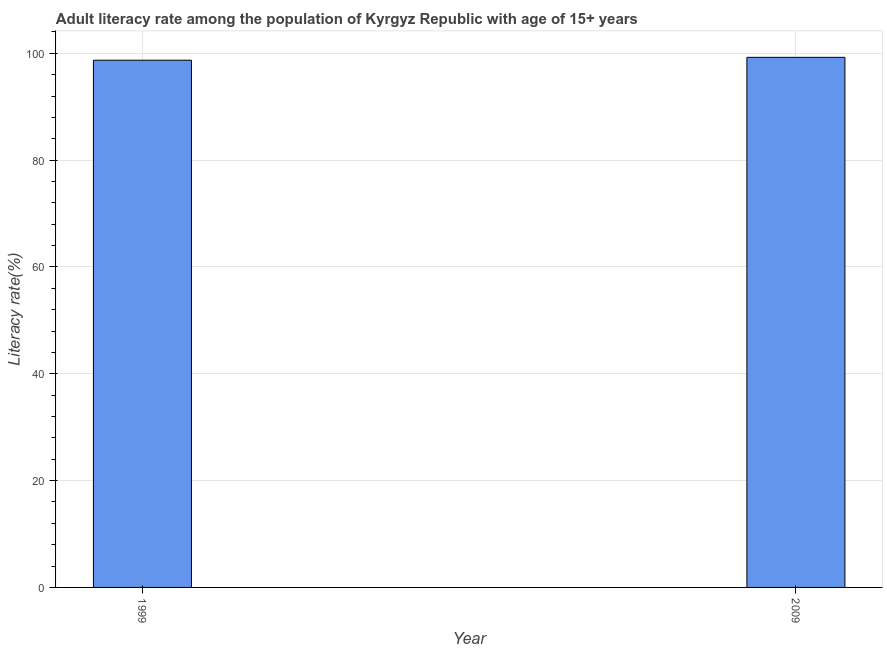What is the title of the graph?
Ensure brevity in your answer.  Adult literacy rate among the population of Kyrgyz Republic with age of 15+ years. What is the label or title of the X-axis?
Your response must be concise. Year. What is the label or title of the Y-axis?
Keep it short and to the point. Literacy rate(%). What is the adult literacy rate in 1999?
Provide a short and direct response. 98.7. Across all years, what is the maximum adult literacy rate?
Your answer should be very brief. 99.24. Across all years, what is the minimum adult literacy rate?
Offer a very short reply. 98.7. In which year was the adult literacy rate minimum?
Your response must be concise. 1999. What is the sum of the adult literacy rate?
Your answer should be compact. 197.94. What is the difference between the adult literacy rate in 1999 and 2009?
Your answer should be very brief. -0.54. What is the average adult literacy rate per year?
Keep it short and to the point. 98.97. What is the median adult literacy rate?
Your answer should be compact. 98.97. In how many years, is the adult literacy rate greater than 36 %?
Offer a terse response. 2. Do a majority of the years between 1999 and 2009 (inclusive) have adult literacy rate greater than 4 %?
Your answer should be compact. Yes. What is the ratio of the adult literacy rate in 1999 to that in 2009?
Ensure brevity in your answer.  0.99. Are all the bars in the graph horizontal?
Offer a terse response. No. How many years are there in the graph?
Give a very brief answer. 2. What is the difference between two consecutive major ticks on the Y-axis?
Provide a short and direct response. 20. What is the Literacy rate(%) of 1999?
Give a very brief answer. 98.7. What is the Literacy rate(%) of 2009?
Make the answer very short. 99.24. What is the difference between the Literacy rate(%) in 1999 and 2009?
Your response must be concise. -0.54. 